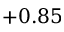Convert formula to latex. <formula><loc_0><loc_0><loc_500><loc_500>+ 0 . 8 5</formula> 